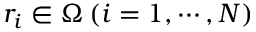<formula> <loc_0><loc_0><loc_500><loc_500>r _ { i } \in \Omega \, ( i = 1 , \cdots , N )</formula> 